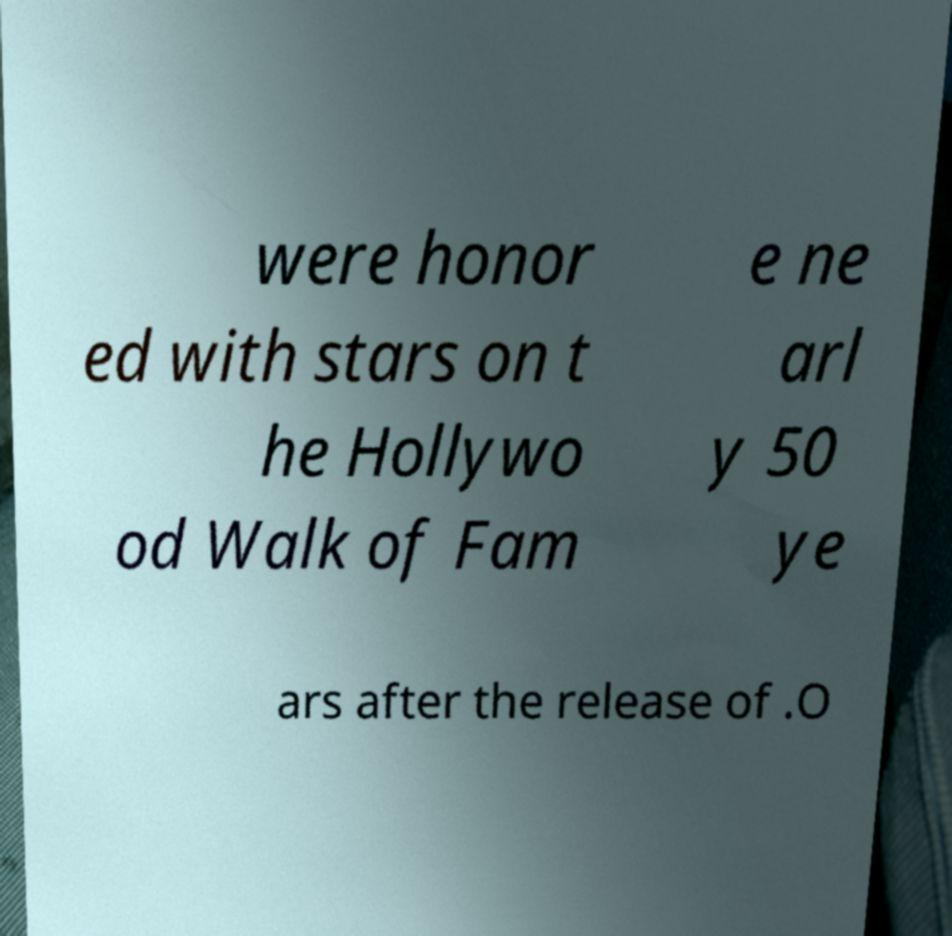Please read and relay the text visible in this image. What does it say? were honor ed with stars on t he Hollywo od Walk of Fam e ne arl y 50 ye ars after the release of .O 